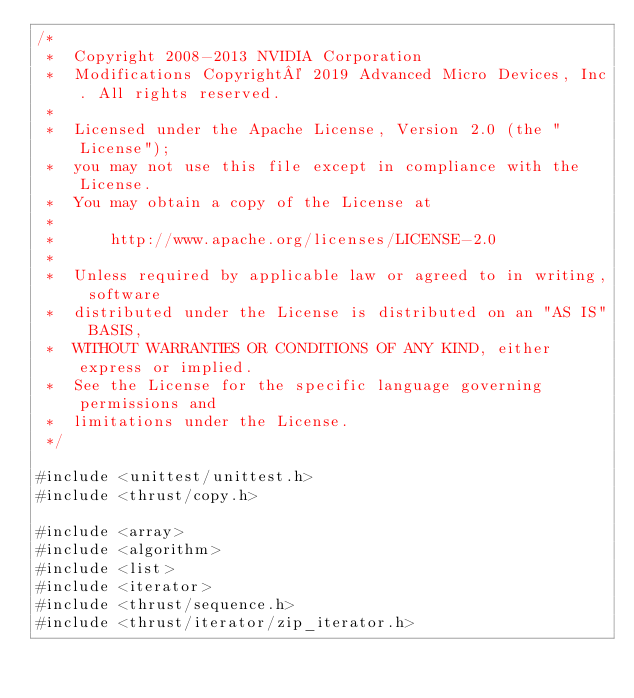<code> <loc_0><loc_0><loc_500><loc_500><_Cuda_>/*
 *  Copyright 2008-2013 NVIDIA Corporation
 *  Modifications Copyright© 2019 Advanced Micro Devices, Inc. All rights reserved.
 *
 *  Licensed under the Apache License, Version 2.0 (the "License");
 *  you may not use this file except in compliance with the License.
 *  You may obtain a copy of the License at
 *
 *      http://www.apache.org/licenses/LICENSE-2.0
 *
 *  Unless required by applicable law or agreed to in writing, software
 *  distributed under the License is distributed on an "AS IS" BASIS,
 *  WITHOUT WARRANTIES OR CONDITIONS OF ANY KIND, either express or implied.
 *  See the License for the specific language governing permissions and
 *  limitations under the License.
 */
 
#include <unittest/unittest.h>
#include <thrust/copy.h>

#include <array>
#include <algorithm>
#include <list>
#include <iterator>
#include <thrust/sequence.h>
#include <thrust/iterator/zip_iterator.h></code> 